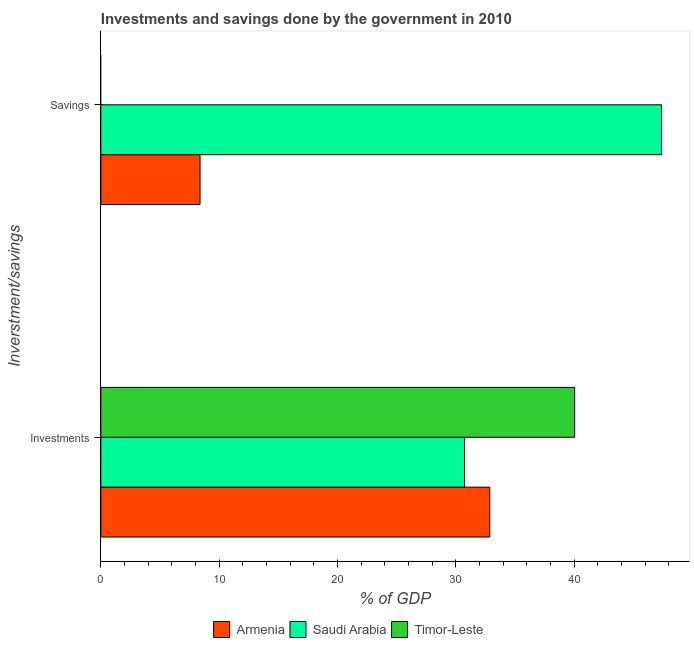How many different coloured bars are there?
Offer a terse response. 3. Are the number of bars per tick equal to the number of legend labels?
Offer a terse response. No. Are the number of bars on each tick of the Y-axis equal?
Ensure brevity in your answer.  No. How many bars are there on the 1st tick from the top?
Provide a short and direct response. 2. What is the label of the 1st group of bars from the top?
Make the answer very short. Savings. What is the savings of government in Saudi Arabia?
Your response must be concise. 47.38. Across all countries, what is the maximum investments of government?
Make the answer very short. 40.04. Across all countries, what is the minimum investments of government?
Provide a succinct answer. 30.74. In which country was the investments of government maximum?
Give a very brief answer. Timor-Leste. What is the total savings of government in the graph?
Give a very brief answer. 55.76. What is the difference between the investments of government in Saudi Arabia and that in Armenia?
Provide a short and direct response. -2.13. What is the difference between the savings of government in Armenia and the investments of government in Timor-Leste?
Ensure brevity in your answer.  -31.66. What is the average savings of government per country?
Your answer should be compact. 18.59. What is the difference between the savings of government and investments of government in Armenia?
Ensure brevity in your answer.  -24.49. In how many countries, is the investments of government greater than 28 %?
Your answer should be compact. 3. What is the ratio of the investments of government in Armenia to that in Timor-Leste?
Offer a terse response. 0.82. Is the investments of government in Saudi Arabia less than that in Timor-Leste?
Your response must be concise. Yes. How many bars are there?
Your response must be concise. 5. Are all the bars in the graph horizontal?
Provide a succinct answer. Yes. Does the graph contain any zero values?
Your answer should be compact. Yes. Does the graph contain grids?
Make the answer very short. No. Where does the legend appear in the graph?
Give a very brief answer. Bottom center. What is the title of the graph?
Your answer should be compact. Investments and savings done by the government in 2010. What is the label or title of the X-axis?
Keep it short and to the point. % of GDP. What is the label or title of the Y-axis?
Offer a terse response. Inverstment/savings. What is the % of GDP of Armenia in Investments?
Give a very brief answer. 32.87. What is the % of GDP in Saudi Arabia in Investments?
Provide a short and direct response. 30.74. What is the % of GDP of Timor-Leste in Investments?
Offer a very short reply. 40.04. What is the % of GDP in Armenia in Savings?
Your answer should be compact. 8.38. What is the % of GDP of Saudi Arabia in Savings?
Give a very brief answer. 47.38. Across all Inverstment/savings, what is the maximum % of GDP in Armenia?
Give a very brief answer. 32.87. Across all Inverstment/savings, what is the maximum % of GDP in Saudi Arabia?
Make the answer very short. 47.38. Across all Inverstment/savings, what is the maximum % of GDP of Timor-Leste?
Provide a succinct answer. 40.04. Across all Inverstment/savings, what is the minimum % of GDP of Armenia?
Your answer should be very brief. 8.38. Across all Inverstment/savings, what is the minimum % of GDP of Saudi Arabia?
Provide a short and direct response. 30.74. What is the total % of GDP of Armenia in the graph?
Your response must be concise. 41.25. What is the total % of GDP in Saudi Arabia in the graph?
Provide a short and direct response. 78.12. What is the total % of GDP in Timor-Leste in the graph?
Give a very brief answer. 40.04. What is the difference between the % of GDP in Armenia in Investments and that in Savings?
Make the answer very short. 24.49. What is the difference between the % of GDP in Saudi Arabia in Investments and that in Savings?
Your response must be concise. -16.63. What is the difference between the % of GDP in Armenia in Investments and the % of GDP in Saudi Arabia in Savings?
Keep it short and to the point. -14.51. What is the average % of GDP of Armenia per Inverstment/savings?
Keep it short and to the point. 20.63. What is the average % of GDP of Saudi Arabia per Inverstment/savings?
Your response must be concise. 39.06. What is the average % of GDP in Timor-Leste per Inverstment/savings?
Offer a very short reply. 20.02. What is the difference between the % of GDP of Armenia and % of GDP of Saudi Arabia in Investments?
Offer a terse response. 2.13. What is the difference between the % of GDP in Armenia and % of GDP in Timor-Leste in Investments?
Provide a short and direct response. -7.17. What is the difference between the % of GDP of Saudi Arabia and % of GDP of Timor-Leste in Investments?
Offer a very short reply. -9.3. What is the difference between the % of GDP of Armenia and % of GDP of Saudi Arabia in Savings?
Keep it short and to the point. -38.99. What is the ratio of the % of GDP of Armenia in Investments to that in Savings?
Keep it short and to the point. 3.92. What is the ratio of the % of GDP in Saudi Arabia in Investments to that in Savings?
Provide a short and direct response. 0.65. What is the difference between the highest and the second highest % of GDP of Armenia?
Keep it short and to the point. 24.49. What is the difference between the highest and the second highest % of GDP in Saudi Arabia?
Provide a succinct answer. 16.63. What is the difference between the highest and the lowest % of GDP of Armenia?
Ensure brevity in your answer.  24.49. What is the difference between the highest and the lowest % of GDP in Saudi Arabia?
Your answer should be very brief. 16.63. What is the difference between the highest and the lowest % of GDP of Timor-Leste?
Offer a terse response. 40.04. 